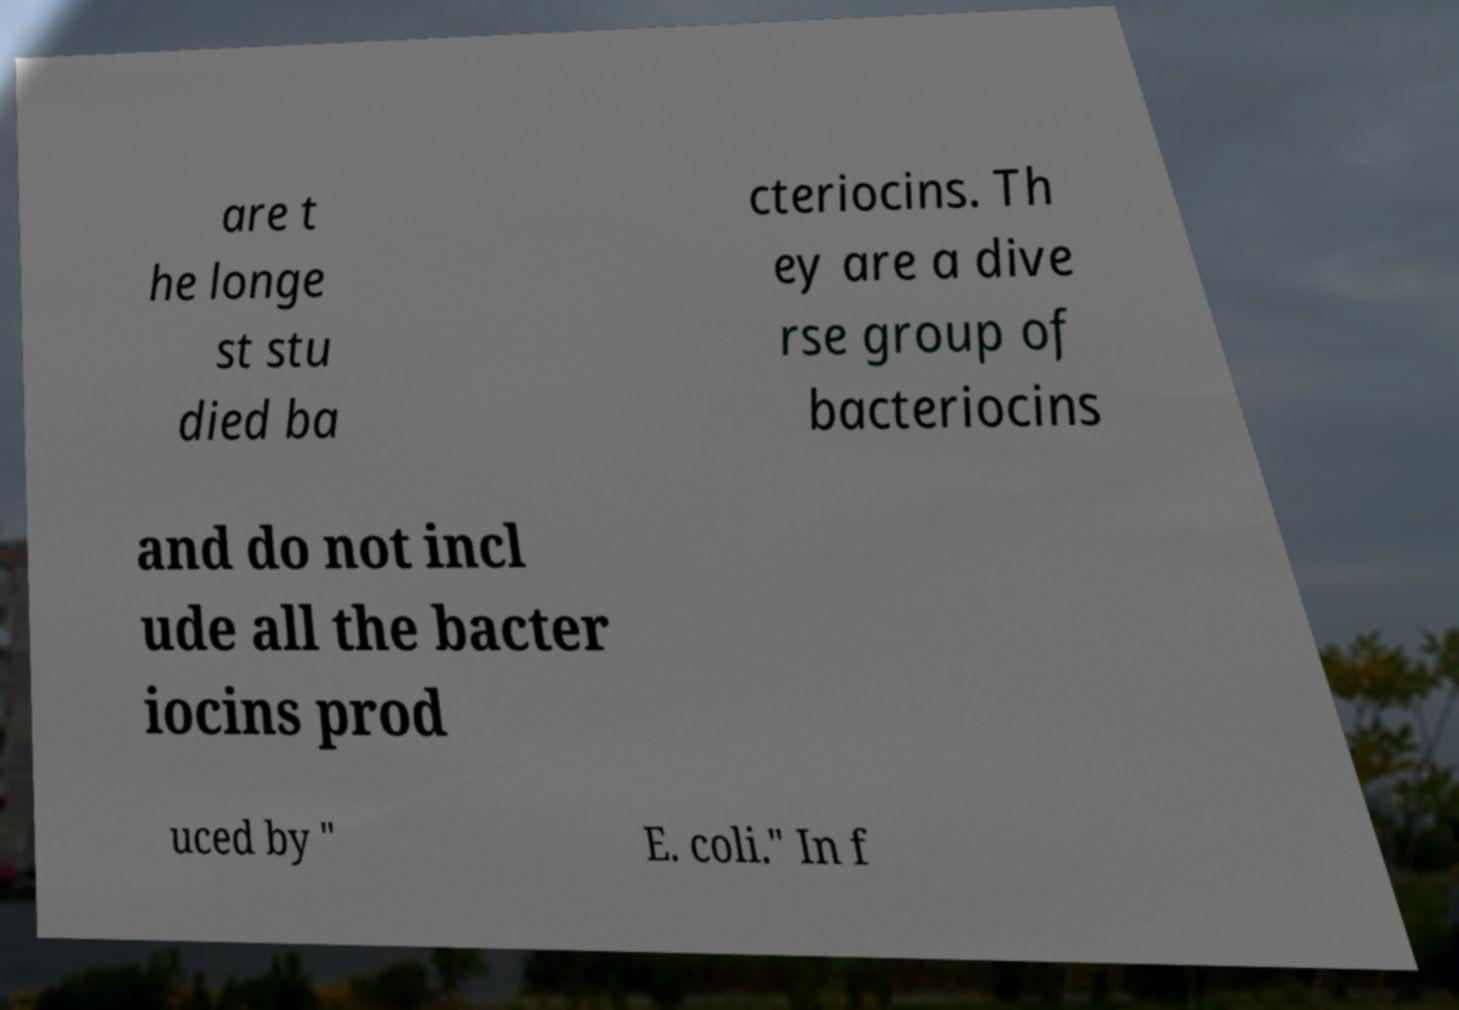Could you extract and type out the text from this image? are t he longe st stu died ba cteriocins. Th ey are a dive rse group of bacteriocins and do not incl ude all the bacter iocins prod uced by " E. coli." In f 